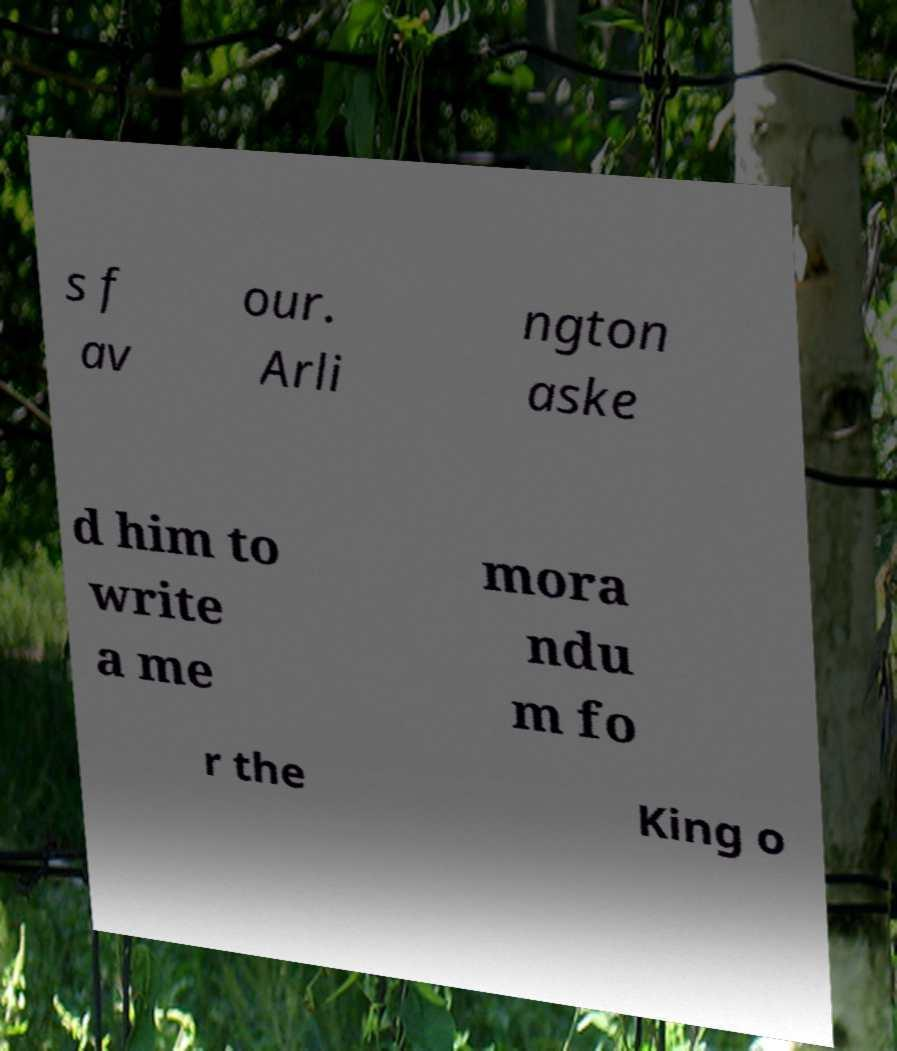I need the written content from this picture converted into text. Can you do that? s f av our. Arli ngton aske d him to write a me mora ndu m fo r the King o 